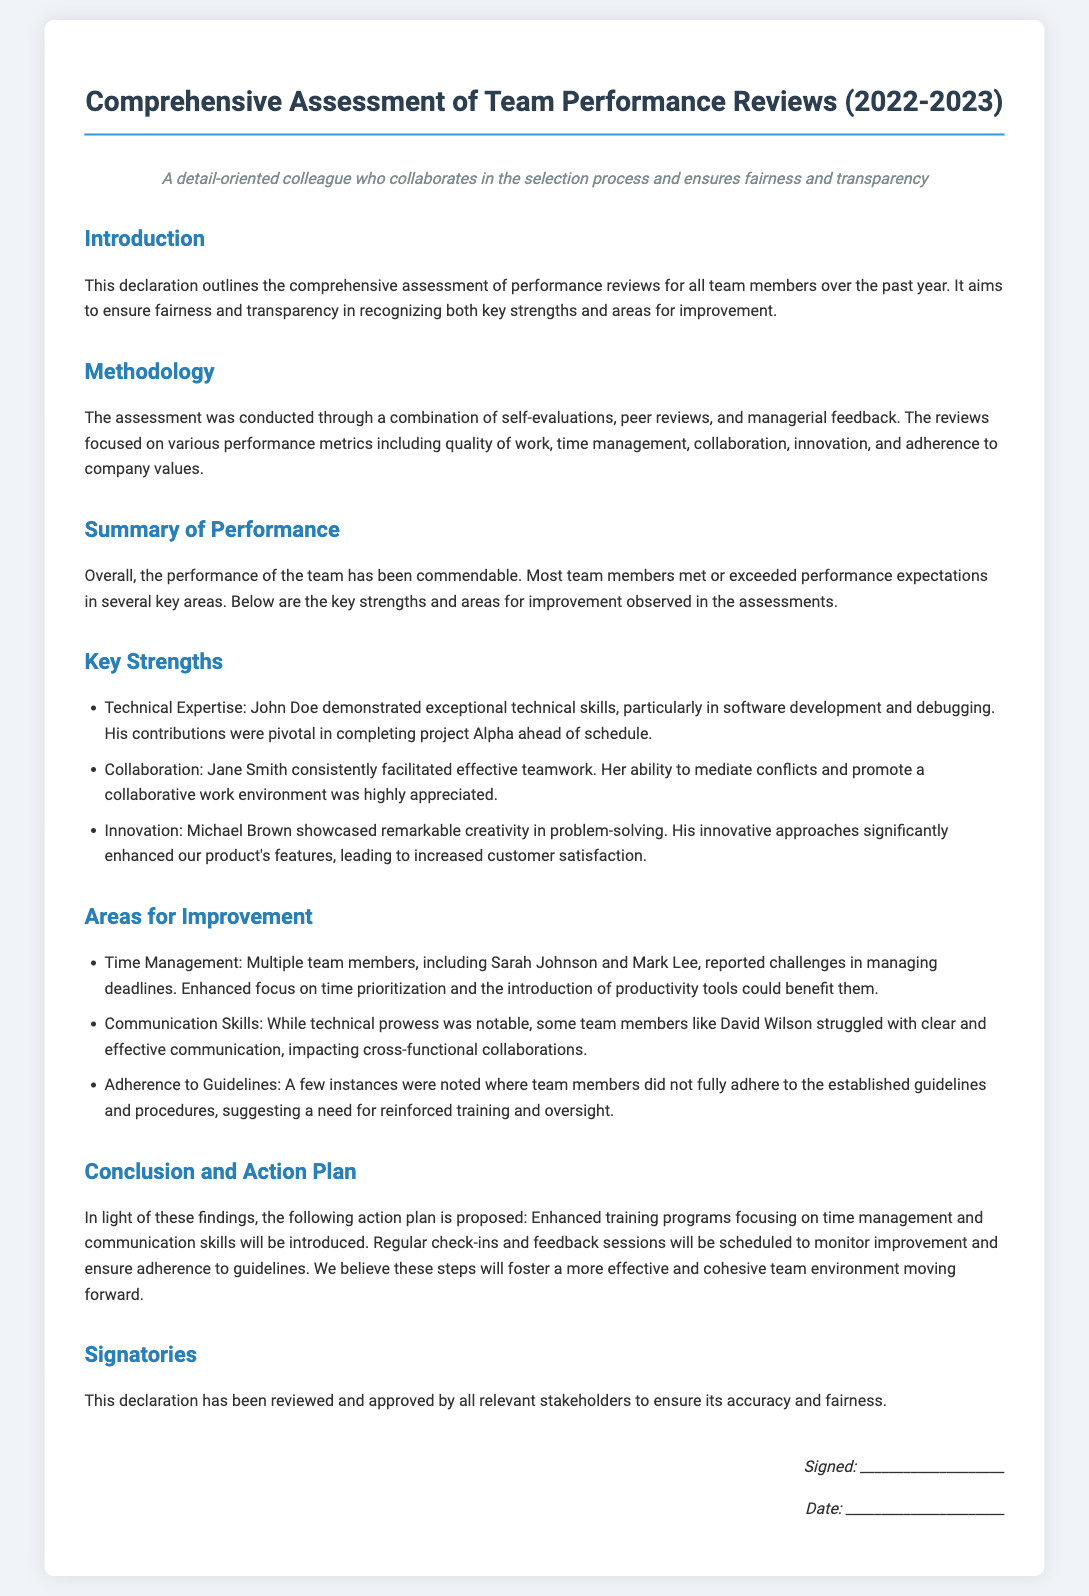What is the title of the document? The title is mentioned at the top of the document, clearly stated in the heading.
Answer: Comprehensive Assessment of Team Performance Reviews (2022-2023) Who demonstrated exceptional technical skills? The document lists team members along with their key strengths, identifying specific individuals for specific traits.
Answer: John Doe What area did multiple team members report challenges in? The assessment reveals common challenges faced by the team, highlighting specific areas for improvement.
Answer: Time Management What is one of Michael Brown's key strengths? The document outlines individual strengths, including specific contributions by each member.
Answer: Creativity in problem-solving What solution is proposed to enhance time management skills? The action plan includes specific strategies to improve identified weaknesses based on the assessment findings.
Answer: Enhanced training programs How many areas for improvement are mentioned? The document categorizes the evaluation findings into strengths and areas for growth; counting these gives us the total for improvement.
Answer: Three Which team member was noted for struggling with communication? The document identifies individuals along with their respective areas for improvement, focusing on specific issues per member.
Answer: David Wilson What will be scheduled to monitor improvement? The conclusion states actions to be taken following the assessment, particularly for following up on the action plan.
Answer: Regular check-ins and feedback sessions Who approved the declaration for accuracy and fairness? The document mentions the involvement of relevant stakeholders in the review process to ensure transparency.
Answer: Relevant stakeholders 